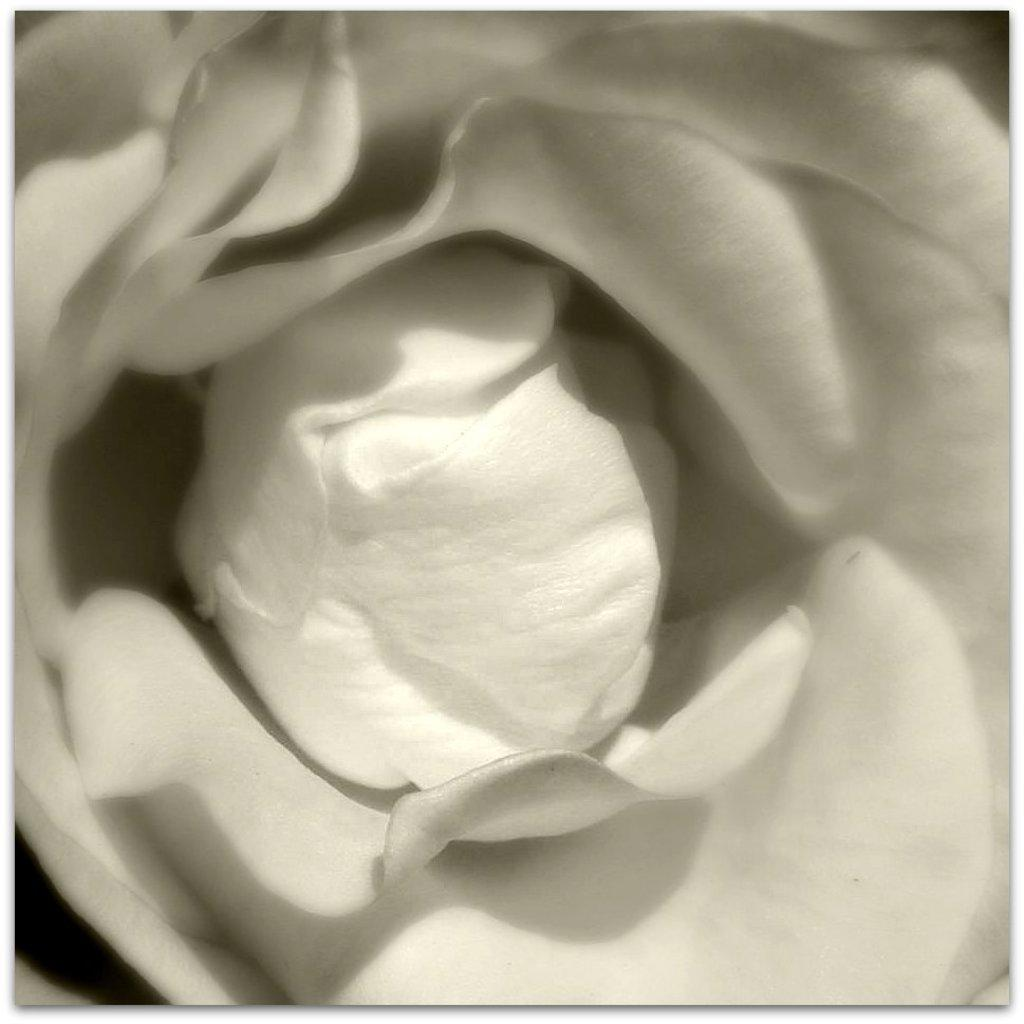What is the main subject of the image? There is a flower in the image. What type of vest is the flower wearing in the image? There is no vest present in the image, as flowers do not wear clothing. 